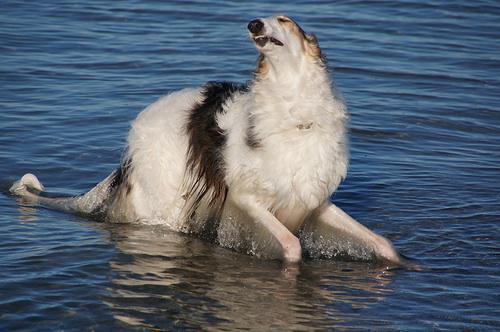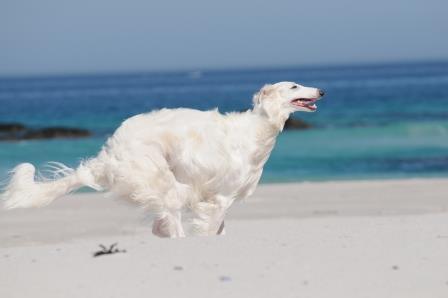The first image is the image on the left, the second image is the image on the right. For the images shown, is this caption "There are at most two dogs." true? Answer yes or no. Yes. The first image is the image on the left, the second image is the image on the right. Given the left and right images, does the statement "At least one of the dogs is near a body of water." hold true? Answer yes or no. Yes. 